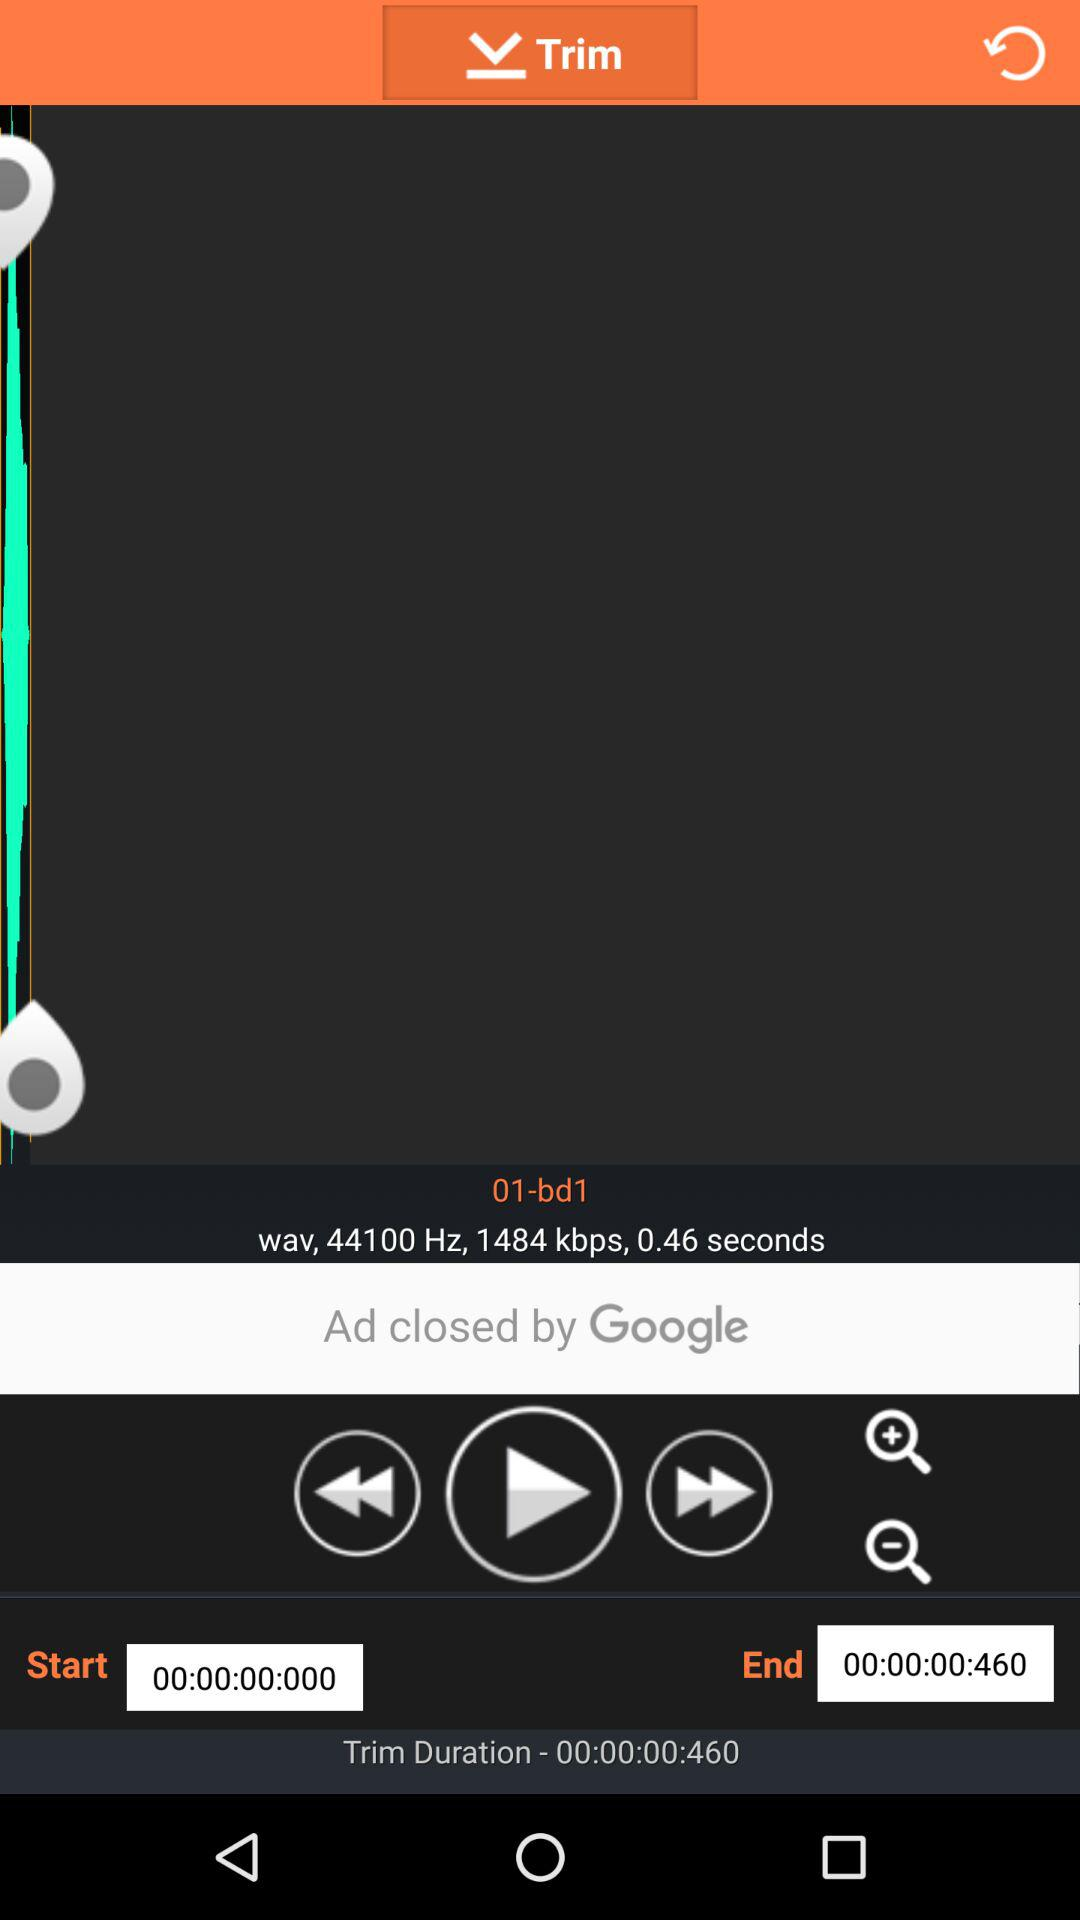What is the start time? The start time is 00:00:00:000. 